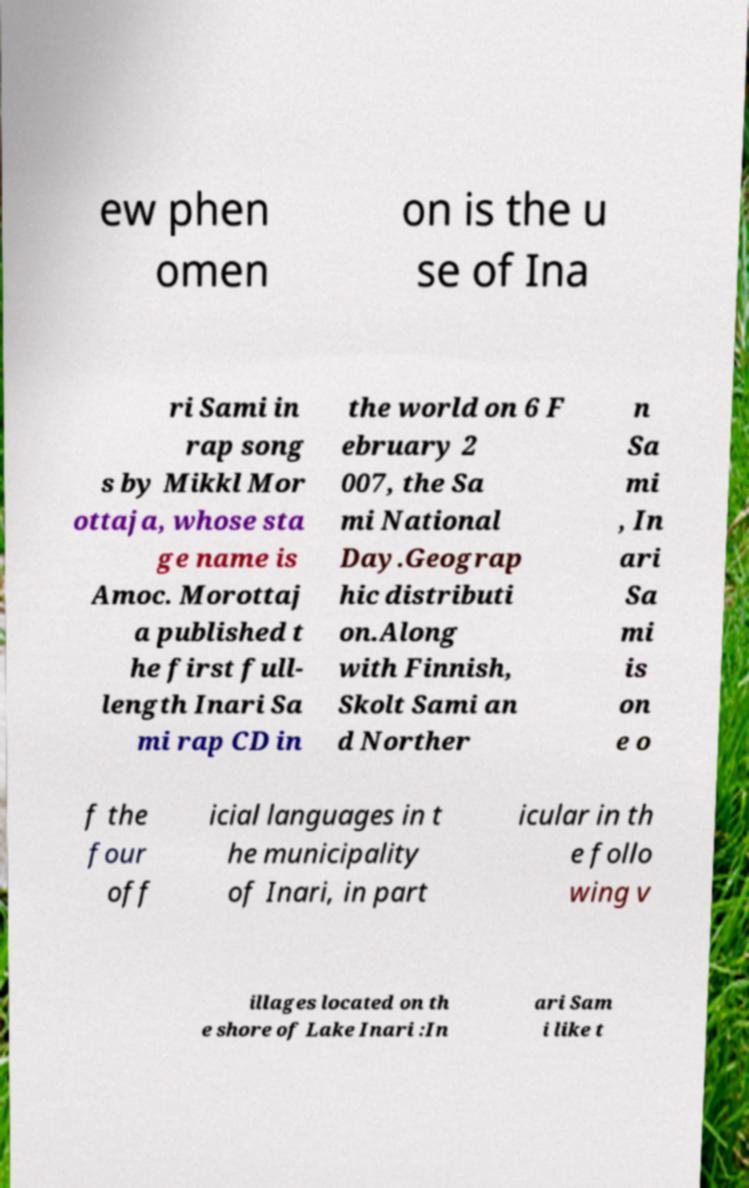Please identify and transcribe the text found in this image. ew phen omen on is the u se of Ina ri Sami in rap song s by Mikkl Mor ottaja, whose sta ge name is Amoc. Morottaj a published t he first full- length Inari Sa mi rap CD in the world on 6 F ebruary 2 007, the Sa mi National Day.Geograp hic distributi on.Along with Finnish, Skolt Sami an d Norther n Sa mi , In ari Sa mi is on e o f the four off icial languages in t he municipality of Inari, in part icular in th e follo wing v illages located on th e shore of Lake Inari :In ari Sam i like t 